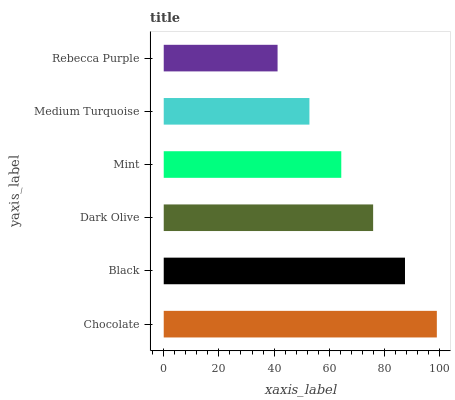Is Rebecca Purple the minimum?
Answer yes or no. Yes. Is Chocolate the maximum?
Answer yes or no. Yes. Is Black the minimum?
Answer yes or no. No. Is Black the maximum?
Answer yes or no. No. Is Chocolate greater than Black?
Answer yes or no. Yes. Is Black less than Chocolate?
Answer yes or no. Yes. Is Black greater than Chocolate?
Answer yes or no. No. Is Chocolate less than Black?
Answer yes or no. No. Is Dark Olive the high median?
Answer yes or no. Yes. Is Mint the low median?
Answer yes or no. Yes. Is Chocolate the high median?
Answer yes or no. No. Is Rebecca Purple the low median?
Answer yes or no. No. 